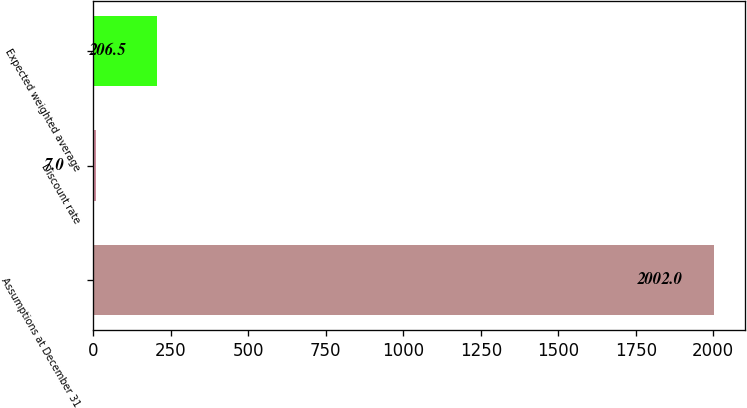Convert chart to OTSL. <chart><loc_0><loc_0><loc_500><loc_500><bar_chart><fcel>Assumptions at December 31<fcel>Discount rate<fcel>Expected weighted average<nl><fcel>2002<fcel>7<fcel>206.5<nl></chart> 